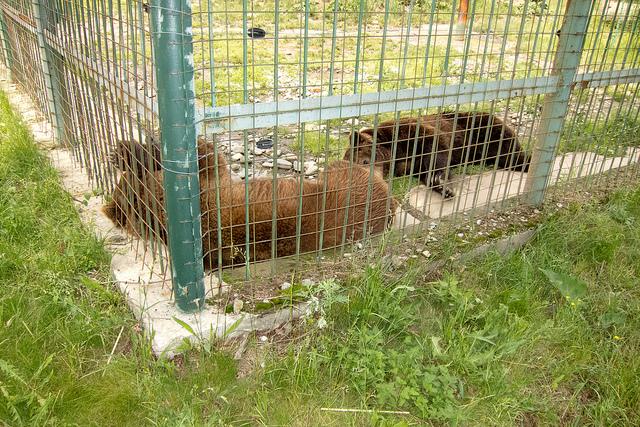What animals are in the cages?
Quick response, please. Bears. Is this a jail?
Give a very brief answer. No. How many animals are laying down?
Short answer required. 2. 